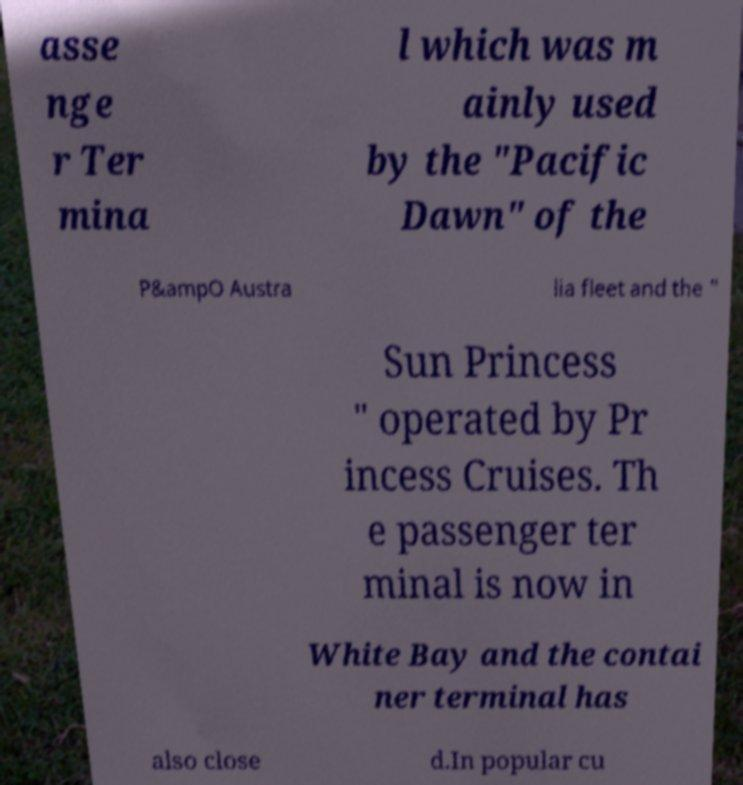Could you extract and type out the text from this image? asse nge r Ter mina l which was m ainly used by the "Pacific Dawn" of the P&ampO Austra lia fleet and the " Sun Princess " operated by Pr incess Cruises. Th e passenger ter minal is now in White Bay and the contai ner terminal has also close d.In popular cu 